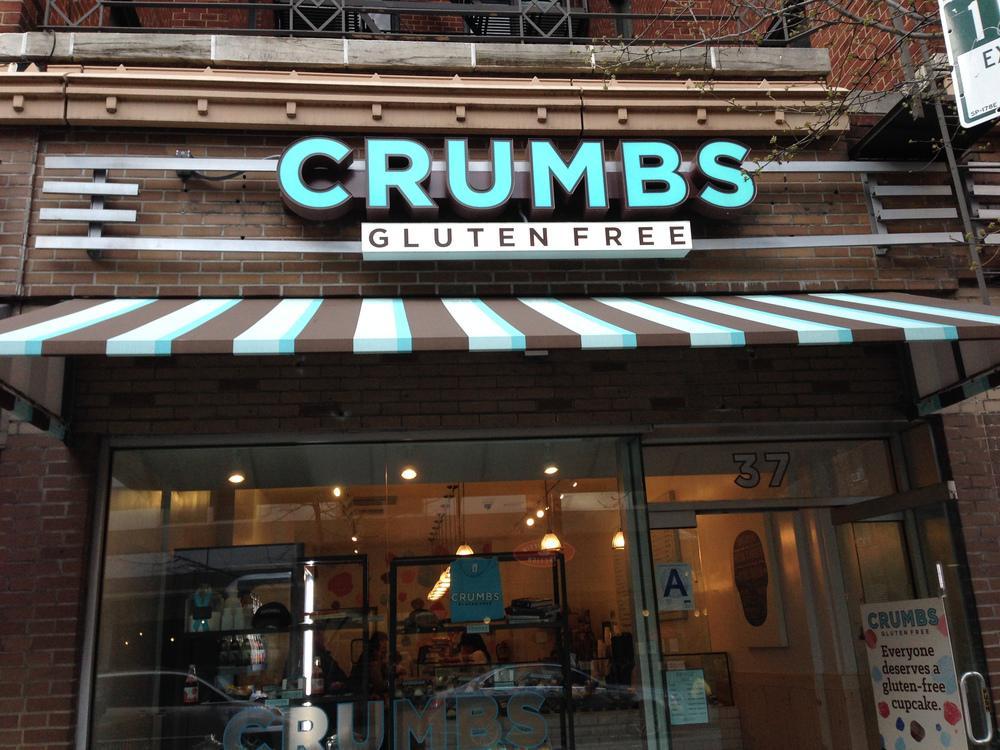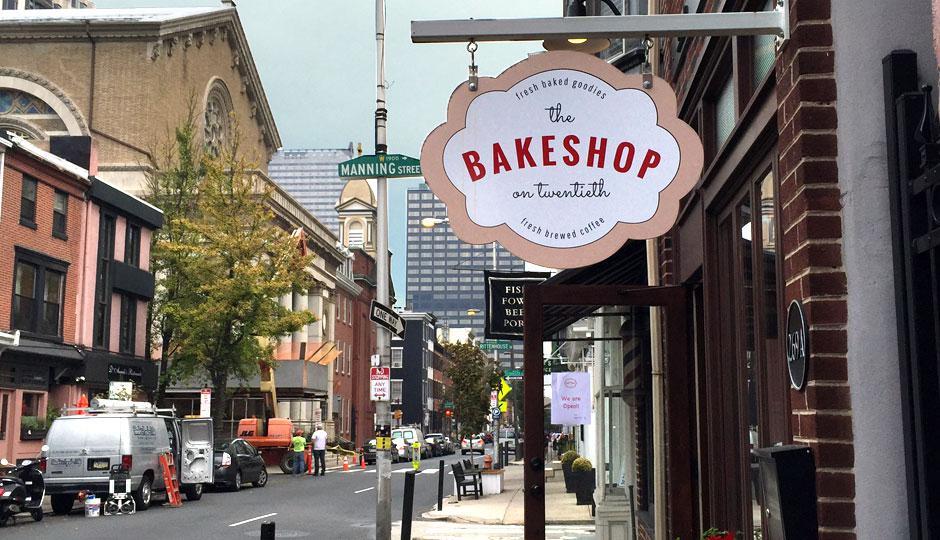The first image is the image on the left, the second image is the image on the right. Analyze the images presented: Is the assertion "A red and black awning hangs over the entrance in the image on the left." valid? Answer yes or no. No. 